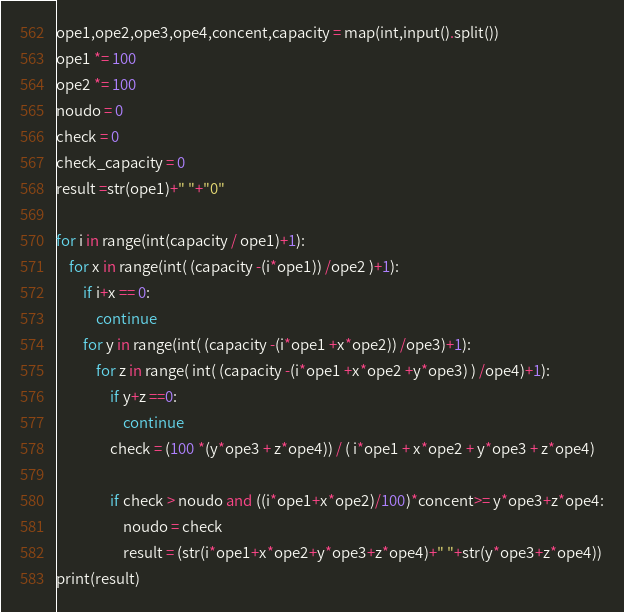<code> <loc_0><loc_0><loc_500><loc_500><_Python_>ope1,ope2,ope3,ope4,concent,capacity = map(int,input().split())
ope1 *= 100
ope2 *= 100
noudo = 0
check = 0
check_capacity = 0
result =str(ope1)+" "+"0"

for i in range(int(capacity / ope1)+1):
    for x in range(int( (capacity -(i*ope1)) /ope2 )+1):
        if i+x == 0:
            continue
        for y in range(int( (capacity -(i*ope1 +x*ope2)) /ope3)+1):
            for z in range( int( (capacity -(i*ope1 +x*ope2 +y*ope3) ) /ope4)+1):
                if y+z ==0:
                    continue
                check = (100 *(y*ope3 + z*ope4)) / ( i*ope1 + x*ope2 + y*ope3 + z*ope4)

                if check > noudo and ((i*ope1+x*ope2)/100)*concent>= y*ope3+z*ope4:
                    noudo = check
                    result = (str(i*ope1+x*ope2+y*ope3+z*ope4)+" "+str(y*ope3+z*ope4))
print(result)</code> 